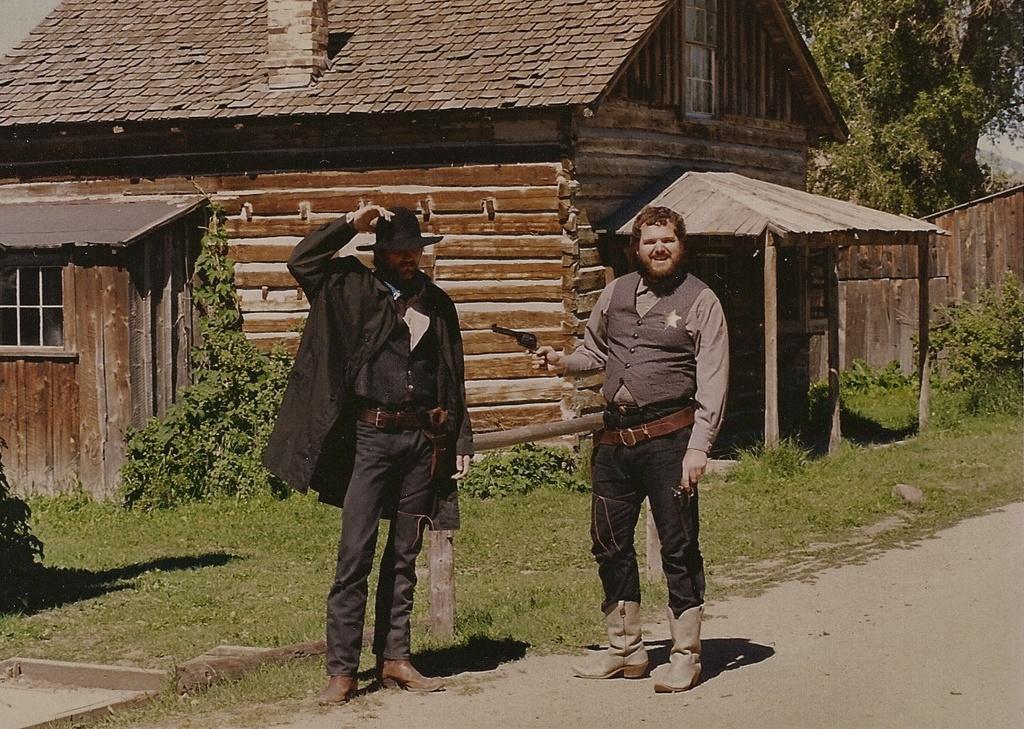Can you describe this image briefly? In this image we can see two men are standing on the road. One man is wearing black color jacket and jeans. And the other one is wearing shirt with black color jeans. Behind them houseplant, grassy land and tree is there. 